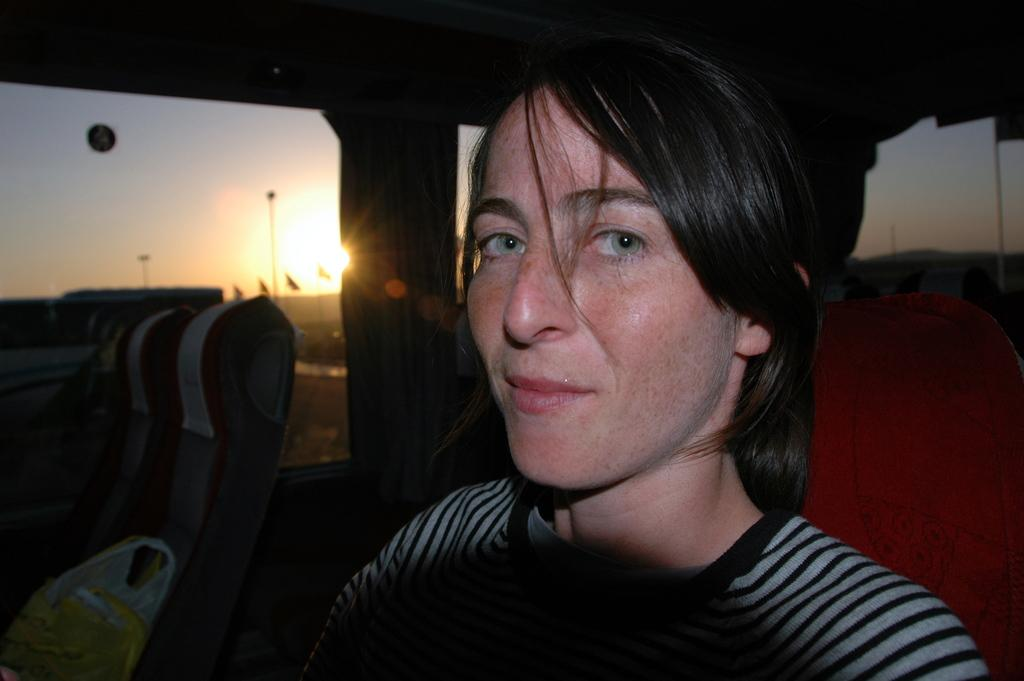Who is present in the image? There is a woman in the image. What is the woman doing in the image? The woman is sitting. What is the woman's facial expression in the image? The woman is smiling. What can be seen through the window in the image? The sun and sky are visible from the window. What type of beast can be seen causing a loss in the image? There is no beast causing a loss present in the image. 